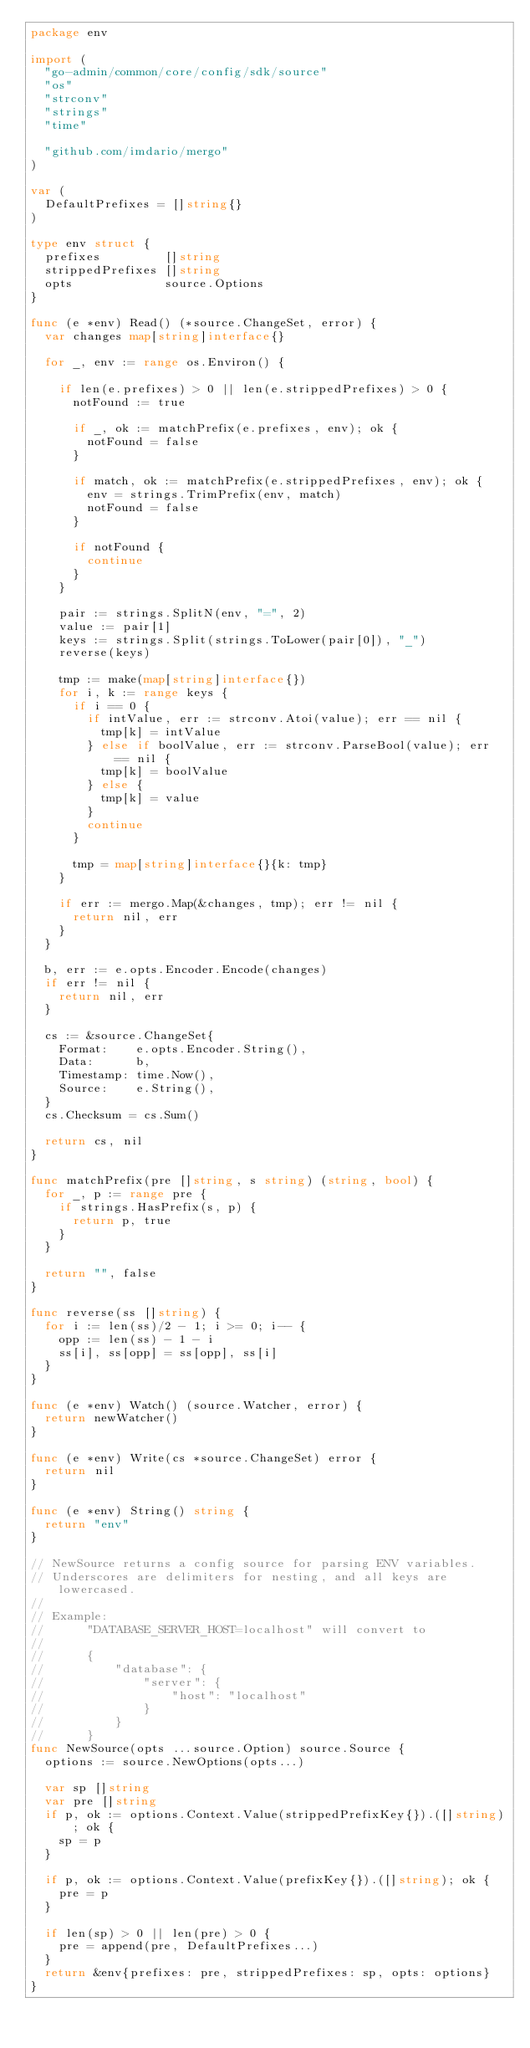<code> <loc_0><loc_0><loc_500><loc_500><_Go_>package env

import (
	"go-admin/common/core/config/sdk/source"
	"os"
	"strconv"
	"strings"
	"time"

	"github.com/imdario/mergo"
)

var (
	DefaultPrefixes = []string{}
)

type env struct {
	prefixes         []string
	strippedPrefixes []string
	opts             source.Options
}

func (e *env) Read() (*source.ChangeSet, error) {
	var changes map[string]interface{}

	for _, env := range os.Environ() {

		if len(e.prefixes) > 0 || len(e.strippedPrefixes) > 0 {
			notFound := true

			if _, ok := matchPrefix(e.prefixes, env); ok {
				notFound = false
			}

			if match, ok := matchPrefix(e.strippedPrefixes, env); ok {
				env = strings.TrimPrefix(env, match)
				notFound = false
			}

			if notFound {
				continue
			}
		}

		pair := strings.SplitN(env, "=", 2)
		value := pair[1]
		keys := strings.Split(strings.ToLower(pair[0]), "_")
		reverse(keys)

		tmp := make(map[string]interface{})
		for i, k := range keys {
			if i == 0 {
				if intValue, err := strconv.Atoi(value); err == nil {
					tmp[k] = intValue
				} else if boolValue, err := strconv.ParseBool(value); err == nil {
					tmp[k] = boolValue
				} else {
					tmp[k] = value
				}
				continue
			}

			tmp = map[string]interface{}{k: tmp}
		}

		if err := mergo.Map(&changes, tmp); err != nil {
			return nil, err
		}
	}

	b, err := e.opts.Encoder.Encode(changes)
	if err != nil {
		return nil, err
	}

	cs := &source.ChangeSet{
		Format:    e.opts.Encoder.String(),
		Data:      b,
		Timestamp: time.Now(),
		Source:    e.String(),
	}
	cs.Checksum = cs.Sum()

	return cs, nil
}

func matchPrefix(pre []string, s string) (string, bool) {
	for _, p := range pre {
		if strings.HasPrefix(s, p) {
			return p, true
		}
	}

	return "", false
}

func reverse(ss []string) {
	for i := len(ss)/2 - 1; i >= 0; i-- {
		opp := len(ss) - 1 - i
		ss[i], ss[opp] = ss[opp], ss[i]
	}
}

func (e *env) Watch() (source.Watcher, error) {
	return newWatcher()
}

func (e *env) Write(cs *source.ChangeSet) error {
	return nil
}

func (e *env) String() string {
	return "env"
}

// NewSource returns a config source for parsing ENV variables.
// Underscores are delimiters for nesting, and all keys are lowercased.
//
// Example:
//      "DATABASE_SERVER_HOST=localhost" will convert to
//
//      {
//          "database": {
//              "server": {
//                  "host": "localhost"
//              }
//          }
//      }
func NewSource(opts ...source.Option) source.Source {
	options := source.NewOptions(opts...)

	var sp []string
	var pre []string
	if p, ok := options.Context.Value(strippedPrefixKey{}).([]string); ok {
		sp = p
	}

	if p, ok := options.Context.Value(prefixKey{}).([]string); ok {
		pre = p
	}

	if len(sp) > 0 || len(pre) > 0 {
		pre = append(pre, DefaultPrefixes...)
	}
	return &env{prefixes: pre, strippedPrefixes: sp, opts: options}
}
</code> 